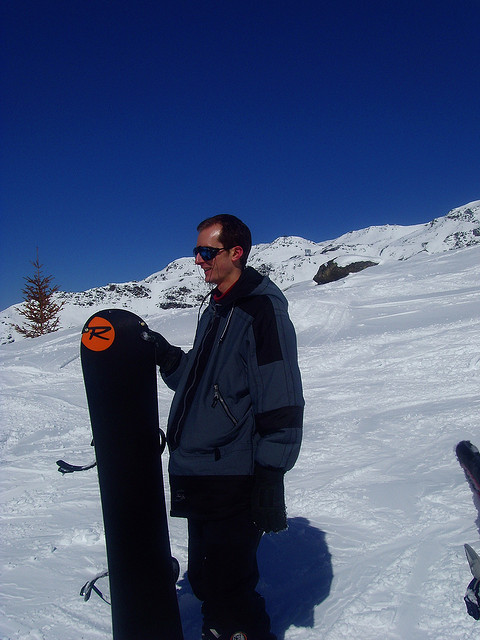Please transcribe the text information in this image. R 